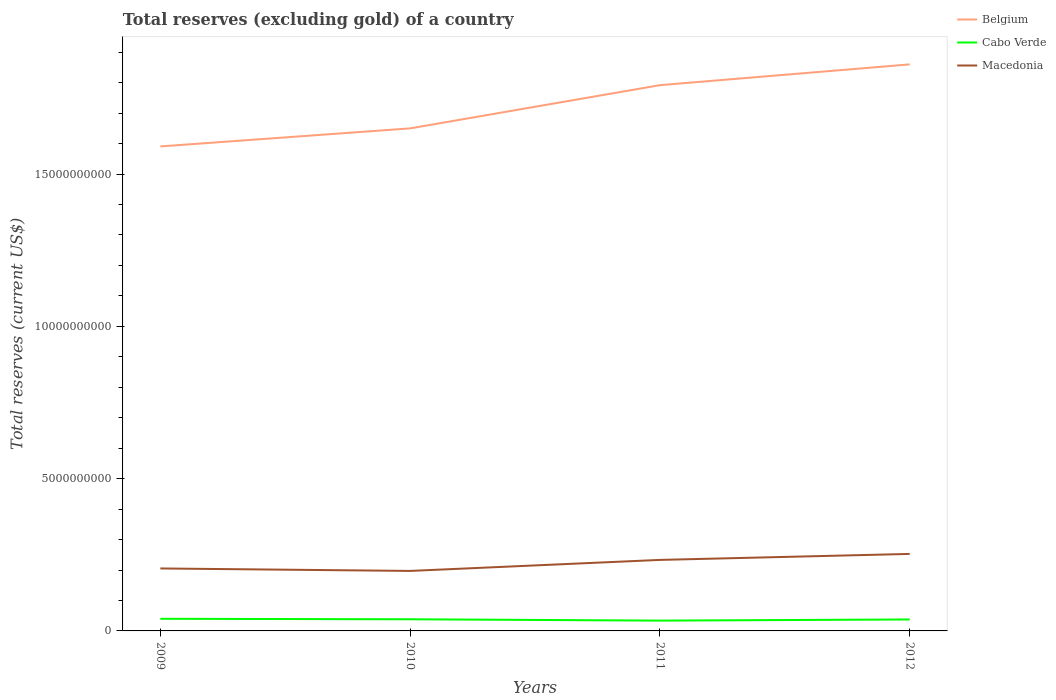Does the line corresponding to Belgium intersect with the line corresponding to Cabo Verde?
Give a very brief answer. No. Is the number of lines equal to the number of legend labels?
Ensure brevity in your answer.  Yes. Across all years, what is the maximum total reserves (excluding gold) in Belgium?
Your response must be concise. 1.59e+1. In which year was the total reserves (excluding gold) in Macedonia maximum?
Provide a short and direct response. 2010. What is the total total reserves (excluding gold) in Macedonia in the graph?
Provide a short and direct response. -2.81e+08. What is the difference between the highest and the second highest total reserves (excluding gold) in Cabo Verde?
Keep it short and to the point. 5.93e+07. What is the difference between the highest and the lowest total reserves (excluding gold) in Belgium?
Offer a very short reply. 2. Is the total reserves (excluding gold) in Belgium strictly greater than the total reserves (excluding gold) in Cabo Verde over the years?
Provide a short and direct response. No. What is the difference between two consecutive major ticks on the Y-axis?
Provide a succinct answer. 5.00e+09. Where does the legend appear in the graph?
Ensure brevity in your answer.  Top right. How are the legend labels stacked?
Your response must be concise. Vertical. What is the title of the graph?
Make the answer very short. Total reserves (excluding gold) of a country. Does "Jordan" appear as one of the legend labels in the graph?
Keep it short and to the point. No. What is the label or title of the Y-axis?
Ensure brevity in your answer.  Total reserves (current US$). What is the Total reserves (current US$) in Belgium in 2009?
Your response must be concise. 1.59e+1. What is the Total reserves (current US$) in Cabo Verde in 2009?
Offer a terse response. 3.98e+08. What is the Total reserves (current US$) of Macedonia in 2009?
Offer a very short reply. 2.05e+09. What is the Total reserves (current US$) in Belgium in 2010?
Offer a very short reply. 1.65e+1. What is the Total reserves (current US$) in Cabo Verde in 2010?
Keep it short and to the point. 3.82e+08. What is the Total reserves (current US$) in Macedonia in 2010?
Your answer should be compact. 1.97e+09. What is the Total reserves (current US$) of Belgium in 2011?
Offer a very short reply. 1.79e+1. What is the Total reserves (current US$) in Cabo Verde in 2011?
Offer a terse response. 3.39e+08. What is the Total reserves (current US$) of Macedonia in 2011?
Ensure brevity in your answer.  2.33e+09. What is the Total reserves (current US$) of Belgium in 2012?
Your response must be concise. 1.86e+1. What is the Total reserves (current US$) in Cabo Verde in 2012?
Offer a terse response. 3.76e+08. What is the Total reserves (current US$) of Macedonia in 2012?
Provide a short and direct response. 2.53e+09. Across all years, what is the maximum Total reserves (current US$) of Belgium?
Provide a succinct answer. 1.86e+1. Across all years, what is the maximum Total reserves (current US$) of Cabo Verde?
Make the answer very short. 3.98e+08. Across all years, what is the maximum Total reserves (current US$) in Macedonia?
Keep it short and to the point. 2.53e+09. Across all years, what is the minimum Total reserves (current US$) of Belgium?
Your answer should be very brief. 1.59e+1. Across all years, what is the minimum Total reserves (current US$) in Cabo Verde?
Your response must be concise. 3.39e+08. Across all years, what is the minimum Total reserves (current US$) of Macedonia?
Keep it short and to the point. 1.97e+09. What is the total Total reserves (current US$) of Belgium in the graph?
Your answer should be compact. 6.89e+1. What is the total Total reserves (current US$) in Cabo Verde in the graph?
Your response must be concise. 1.49e+09. What is the total Total reserves (current US$) of Macedonia in the graph?
Provide a succinct answer. 8.88e+09. What is the difference between the Total reserves (current US$) of Belgium in 2009 and that in 2010?
Your answer should be very brief. -5.93e+08. What is the difference between the Total reserves (current US$) of Cabo Verde in 2009 and that in 2010?
Give a very brief answer. 1.57e+07. What is the difference between the Total reserves (current US$) of Macedonia in 2009 and that in 2010?
Provide a short and direct response. 8.09e+07. What is the difference between the Total reserves (current US$) in Belgium in 2009 and that in 2011?
Ensure brevity in your answer.  -2.01e+09. What is the difference between the Total reserves (current US$) of Cabo Verde in 2009 and that in 2011?
Make the answer very short. 5.93e+07. What is the difference between the Total reserves (current US$) in Macedonia in 2009 and that in 2011?
Your answer should be compact. -2.81e+08. What is the difference between the Total reserves (current US$) of Belgium in 2009 and that in 2012?
Your answer should be compact. -2.69e+09. What is the difference between the Total reserves (current US$) of Cabo Verde in 2009 and that in 2012?
Keep it short and to the point. 2.20e+07. What is the difference between the Total reserves (current US$) of Macedonia in 2009 and that in 2012?
Provide a short and direct response. -4.77e+08. What is the difference between the Total reserves (current US$) in Belgium in 2010 and that in 2011?
Your answer should be very brief. -1.42e+09. What is the difference between the Total reserves (current US$) in Cabo Verde in 2010 and that in 2011?
Provide a succinct answer. 4.36e+07. What is the difference between the Total reserves (current US$) in Macedonia in 2010 and that in 2011?
Provide a short and direct response. -3.61e+08. What is the difference between the Total reserves (current US$) of Belgium in 2010 and that in 2012?
Provide a succinct answer. -2.10e+09. What is the difference between the Total reserves (current US$) in Cabo Verde in 2010 and that in 2012?
Offer a terse response. 6.35e+06. What is the difference between the Total reserves (current US$) of Macedonia in 2010 and that in 2012?
Give a very brief answer. -5.58e+08. What is the difference between the Total reserves (current US$) of Belgium in 2011 and that in 2012?
Give a very brief answer. -6.82e+08. What is the difference between the Total reserves (current US$) of Cabo Verde in 2011 and that in 2012?
Keep it short and to the point. -3.72e+07. What is the difference between the Total reserves (current US$) in Macedonia in 2011 and that in 2012?
Ensure brevity in your answer.  -1.97e+08. What is the difference between the Total reserves (current US$) of Belgium in 2009 and the Total reserves (current US$) of Cabo Verde in 2010?
Ensure brevity in your answer.  1.55e+1. What is the difference between the Total reserves (current US$) in Belgium in 2009 and the Total reserves (current US$) in Macedonia in 2010?
Offer a terse response. 1.39e+1. What is the difference between the Total reserves (current US$) in Cabo Verde in 2009 and the Total reserves (current US$) in Macedonia in 2010?
Your response must be concise. -1.57e+09. What is the difference between the Total reserves (current US$) of Belgium in 2009 and the Total reserves (current US$) of Cabo Verde in 2011?
Offer a very short reply. 1.56e+1. What is the difference between the Total reserves (current US$) in Belgium in 2009 and the Total reserves (current US$) in Macedonia in 2011?
Your response must be concise. 1.36e+1. What is the difference between the Total reserves (current US$) of Cabo Verde in 2009 and the Total reserves (current US$) of Macedonia in 2011?
Offer a terse response. -1.93e+09. What is the difference between the Total reserves (current US$) of Belgium in 2009 and the Total reserves (current US$) of Cabo Verde in 2012?
Your answer should be very brief. 1.55e+1. What is the difference between the Total reserves (current US$) of Belgium in 2009 and the Total reserves (current US$) of Macedonia in 2012?
Provide a succinct answer. 1.34e+1. What is the difference between the Total reserves (current US$) of Cabo Verde in 2009 and the Total reserves (current US$) of Macedonia in 2012?
Ensure brevity in your answer.  -2.13e+09. What is the difference between the Total reserves (current US$) of Belgium in 2010 and the Total reserves (current US$) of Cabo Verde in 2011?
Keep it short and to the point. 1.62e+1. What is the difference between the Total reserves (current US$) in Belgium in 2010 and the Total reserves (current US$) in Macedonia in 2011?
Your response must be concise. 1.42e+1. What is the difference between the Total reserves (current US$) of Cabo Verde in 2010 and the Total reserves (current US$) of Macedonia in 2011?
Your response must be concise. -1.95e+09. What is the difference between the Total reserves (current US$) of Belgium in 2010 and the Total reserves (current US$) of Cabo Verde in 2012?
Provide a short and direct response. 1.61e+1. What is the difference between the Total reserves (current US$) of Belgium in 2010 and the Total reserves (current US$) of Macedonia in 2012?
Keep it short and to the point. 1.40e+1. What is the difference between the Total reserves (current US$) in Cabo Verde in 2010 and the Total reserves (current US$) in Macedonia in 2012?
Make the answer very short. -2.15e+09. What is the difference between the Total reserves (current US$) in Belgium in 2011 and the Total reserves (current US$) in Cabo Verde in 2012?
Your answer should be compact. 1.75e+1. What is the difference between the Total reserves (current US$) in Belgium in 2011 and the Total reserves (current US$) in Macedonia in 2012?
Your response must be concise. 1.54e+1. What is the difference between the Total reserves (current US$) of Cabo Verde in 2011 and the Total reserves (current US$) of Macedonia in 2012?
Your answer should be compact. -2.19e+09. What is the average Total reserves (current US$) of Belgium per year?
Make the answer very short. 1.72e+1. What is the average Total reserves (current US$) of Cabo Verde per year?
Offer a very short reply. 3.74e+08. What is the average Total reserves (current US$) in Macedonia per year?
Ensure brevity in your answer.  2.22e+09. In the year 2009, what is the difference between the Total reserves (current US$) of Belgium and Total reserves (current US$) of Cabo Verde?
Give a very brief answer. 1.55e+1. In the year 2009, what is the difference between the Total reserves (current US$) of Belgium and Total reserves (current US$) of Macedonia?
Provide a succinct answer. 1.39e+1. In the year 2009, what is the difference between the Total reserves (current US$) in Cabo Verde and Total reserves (current US$) in Macedonia?
Make the answer very short. -1.65e+09. In the year 2010, what is the difference between the Total reserves (current US$) of Belgium and Total reserves (current US$) of Cabo Verde?
Provide a succinct answer. 1.61e+1. In the year 2010, what is the difference between the Total reserves (current US$) in Belgium and Total reserves (current US$) in Macedonia?
Provide a succinct answer. 1.45e+1. In the year 2010, what is the difference between the Total reserves (current US$) of Cabo Verde and Total reserves (current US$) of Macedonia?
Keep it short and to the point. -1.59e+09. In the year 2011, what is the difference between the Total reserves (current US$) of Belgium and Total reserves (current US$) of Cabo Verde?
Provide a succinct answer. 1.76e+1. In the year 2011, what is the difference between the Total reserves (current US$) of Belgium and Total reserves (current US$) of Macedonia?
Keep it short and to the point. 1.56e+1. In the year 2011, what is the difference between the Total reserves (current US$) in Cabo Verde and Total reserves (current US$) in Macedonia?
Keep it short and to the point. -1.99e+09. In the year 2012, what is the difference between the Total reserves (current US$) of Belgium and Total reserves (current US$) of Cabo Verde?
Give a very brief answer. 1.82e+1. In the year 2012, what is the difference between the Total reserves (current US$) of Belgium and Total reserves (current US$) of Macedonia?
Your response must be concise. 1.61e+1. In the year 2012, what is the difference between the Total reserves (current US$) in Cabo Verde and Total reserves (current US$) in Macedonia?
Your answer should be very brief. -2.15e+09. What is the ratio of the Total reserves (current US$) of Belgium in 2009 to that in 2010?
Keep it short and to the point. 0.96. What is the ratio of the Total reserves (current US$) in Cabo Verde in 2009 to that in 2010?
Offer a very short reply. 1.04. What is the ratio of the Total reserves (current US$) in Macedonia in 2009 to that in 2010?
Your answer should be very brief. 1.04. What is the ratio of the Total reserves (current US$) in Belgium in 2009 to that in 2011?
Ensure brevity in your answer.  0.89. What is the ratio of the Total reserves (current US$) in Cabo Verde in 2009 to that in 2011?
Give a very brief answer. 1.18. What is the ratio of the Total reserves (current US$) in Macedonia in 2009 to that in 2011?
Your answer should be very brief. 0.88. What is the ratio of the Total reserves (current US$) in Belgium in 2009 to that in 2012?
Give a very brief answer. 0.86. What is the ratio of the Total reserves (current US$) of Cabo Verde in 2009 to that in 2012?
Make the answer very short. 1.06. What is the ratio of the Total reserves (current US$) in Macedonia in 2009 to that in 2012?
Your answer should be very brief. 0.81. What is the ratio of the Total reserves (current US$) in Belgium in 2010 to that in 2011?
Offer a very short reply. 0.92. What is the ratio of the Total reserves (current US$) of Cabo Verde in 2010 to that in 2011?
Provide a short and direct response. 1.13. What is the ratio of the Total reserves (current US$) of Macedonia in 2010 to that in 2011?
Provide a short and direct response. 0.84. What is the ratio of the Total reserves (current US$) of Belgium in 2010 to that in 2012?
Your response must be concise. 0.89. What is the ratio of the Total reserves (current US$) in Cabo Verde in 2010 to that in 2012?
Make the answer very short. 1.02. What is the ratio of the Total reserves (current US$) of Macedonia in 2010 to that in 2012?
Provide a succinct answer. 0.78. What is the ratio of the Total reserves (current US$) of Belgium in 2011 to that in 2012?
Your answer should be compact. 0.96. What is the ratio of the Total reserves (current US$) of Cabo Verde in 2011 to that in 2012?
Offer a terse response. 0.9. What is the ratio of the Total reserves (current US$) of Macedonia in 2011 to that in 2012?
Your answer should be compact. 0.92. What is the difference between the highest and the second highest Total reserves (current US$) of Belgium?
Keep it short and to the point. 6.82e+08. What is the difference between the highest and the second highest Total reserves (current US$) in Cabo Verde?
Give a very brief answer. 1.57e+07. What is the difference between the highest and the second highest Total reserves (current US$) of Macedonia?
Your response must be concise. 1.97e+08. What is the difference between the highest and the lowest Total reserves (current US$) of Belgium?
Provide a short and direct response. 2.69e+09. What is the difference between the highest and the lowest Total reserves (current US$) in Cabo Verde?
Your response must be concise. 5.93e+07. What is the difference between the highest and the lowest Total reserves (current US$) of Macedonia?
Give a very brief answer. 5.58e+08. 